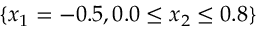Convert formula to latex. <formula><loc_0><loc_0><loc_500><loc_500>\{ x _ { 1 } = - 0 . 5 , 0 . 0 \leq x _ { 2 } \leq 0 . 8 \}</formula> 